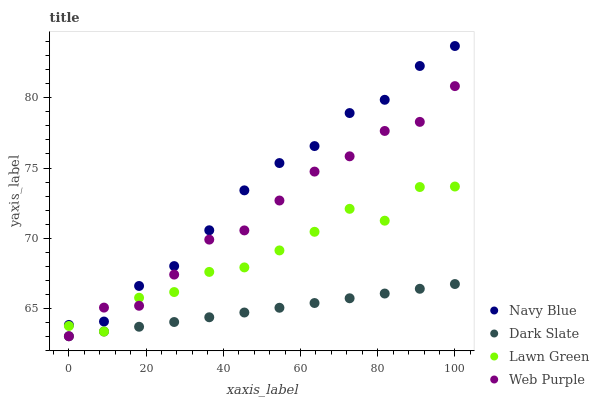Does Dark Slate have the minimum area under the curve?
Answer yes or no. Yes. Does Navy Blue have the maximum area under the curve?
Answer yes or no. Yes. Does Web Purple have the minimum area under the curve?
Answer yes or no. No. Does Web Purple have the maximum area under the curve?
Answer yes or no. No. Is Dark Slate the smoothest?
Answer yes or no. Yes. Is Lawn Green the roughest?
Answer yes or no. Yes. Is Web Purple the smoothest?
Answer yes or no. No. Is Web Purple the roughest?
Answer yes or no. No. Does Web Purple have the lowest value?
Answer yes or no. Yes. Does Lawn Green have the lowest value?
Answer yes or no. No. Does Navy Blue have the highest value?
Answer yes or no. Yes. Does Web Purple have the highest value?
Answer yes or no. No. Is Dark Slate less than Navy Blue?
Answer yes or no. Yes. Is Navy Blue greater than Lawn Green?
Answer yes or no. Yes. Does Dark Slate intersect Lawn Green?
Answer yes or no. Yes. Is Dark Slate less than Lawn Green?
Answer yes or no. No. Is Dark Slate greater than Lawn Green?
Answer yes or no. No. Does Dark Slate intersect Navy Blue?
Answer yes or no. No. 